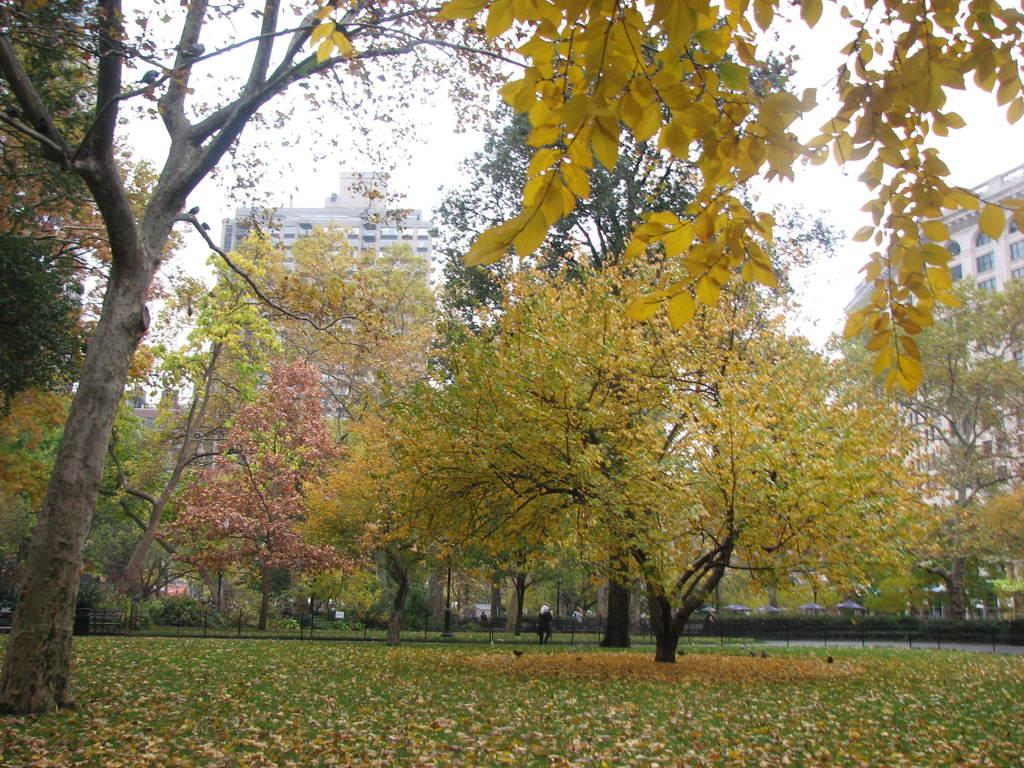What type of vegetation is present in the image? There are many trees and grass in the image. What structures can be seen in the image? There are poles and buildings visible in the image. What is the condition of the ground in the image? Dry leaves are present in the image, indicating that the ground may be dry or covered in fallen leaves. What is visible in the background of the image? The sky and buildings are visible in the background of the image. Are there any people in the image? Yes, there is a person in the image. Reasoning: Let'g: Let's think step by step in order to produce the conversation. We start by identifying the main types of vegetation and structures present in the image. Then, we describe the condition of the ground and the elements visible in the background. Finally, we confirm the presence of a person in the image. Absurd Question/Answer: What type of potato is being used to create art in the image? There is no potato or art present in the image; it features trees, poles, grass, dry leaves, buildings, the sky, and a person. 